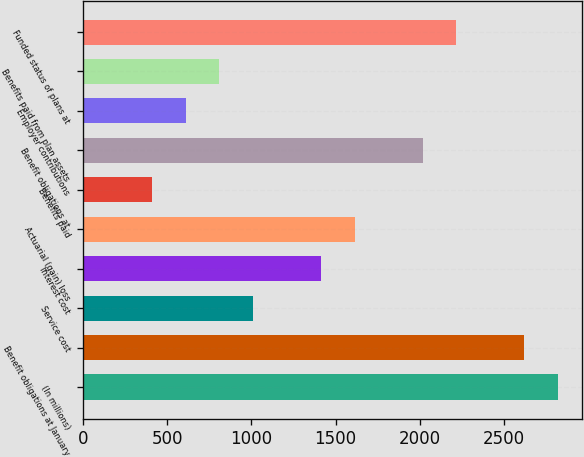Convert chart to OTSL. <chart><loc_0><loc_0><loc_500><loc_500><bar_chart><fcel>(In millions)<fcel>Benefit obligations at January<fcel>Service cost<fcel>Interest cost<fcel>Actuarial (gain) loss<fcel>Benefits paid<fcel>Benefit obligations at<fcel>Employer contributions<fcel>Benefits paid from plan assets<fcel>Funded status of plans at<nl><fcel>2820<fcel>2619<fcel>1011<fcel>1413<fcel>1614<fcel>408<fcel>2016<fcel>609<fcel>810<fcel>2217<nl></chart> 